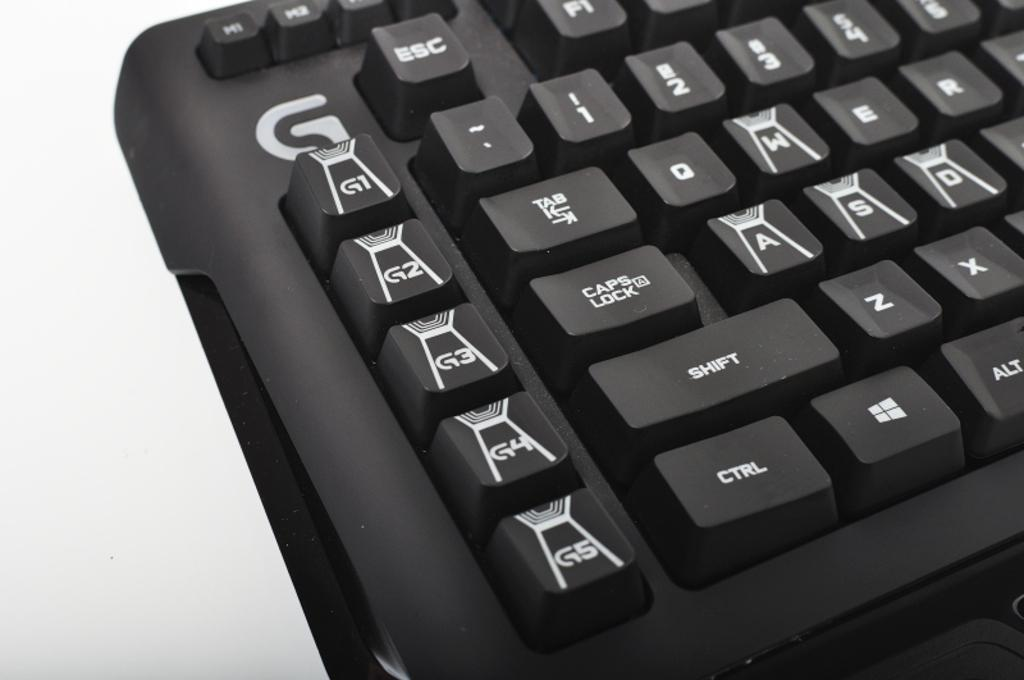Provide a one-sentence caption for the provided image. Different small keys are are placed under a G label on a keyboard. 